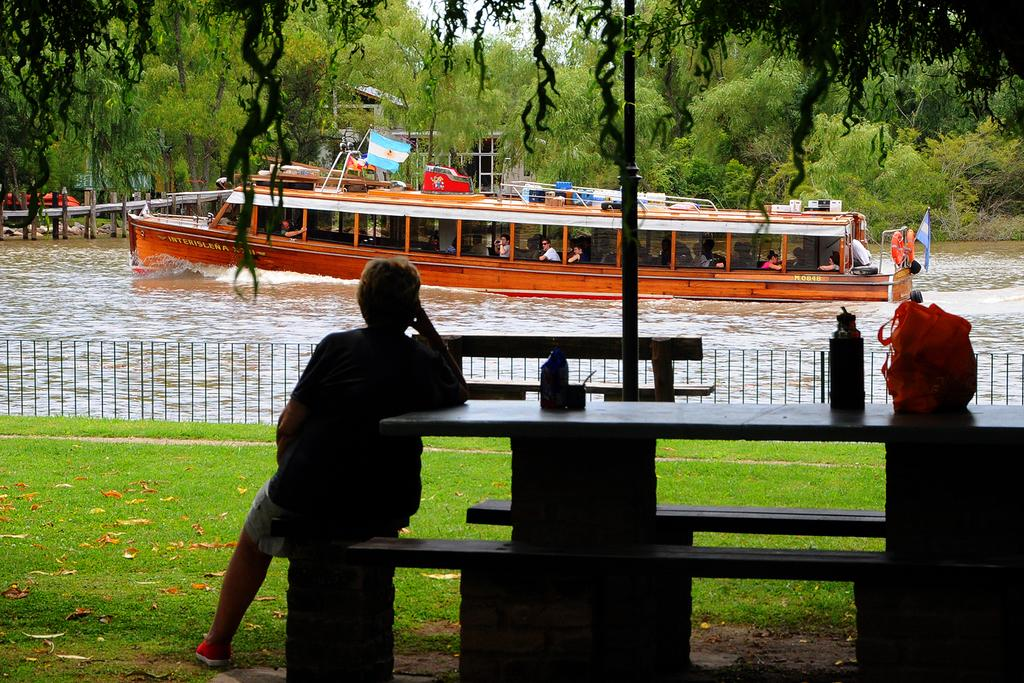What is floating on the water in the image? There is a ship floating on water in the image. What is on top of the ship? There is a flag on top of the ship. Who is sitting on a bench in the image? There is a woman sitting on a bench in the image. What objects are on the table in the image? There is a bottle and an orange parcel on the table in the image. Can you tell me how many times the woman swims around the ship in the image? There is no indication in the image that the woman swims around the ship, so it cannot be determined from the picture. 